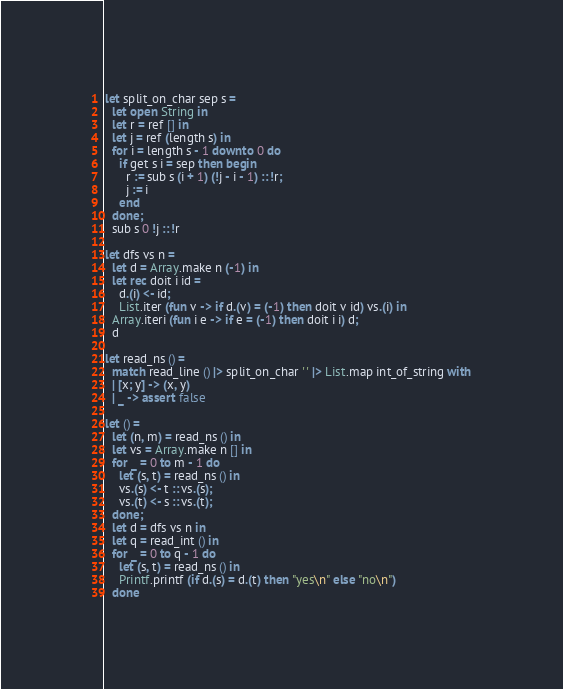<code> <loc_0><loc_0><loc_500><loc_500><_OCaml_>let split_on_char sep s =
  let open String in
  let r = ref [] in
  let j = ref (length s) in
  for i = length s - 1 downto 0 do
    if get s i = sep then begin
      r := sub s (i + 1) (!j - i - 1) :: !r;
      j := i
    end
  done;
  sub s 0 !j :: !r

let dfs vs n =
  let d = Array.make n (-1) in
  let rec doit i id =
    d.(i) <- id;
    List.iter (fun v -> if d.(v) = (-1) then doit v id) vs.(i) in
  Array.iteri (fun i e -> if e = (-1) then doit i i) d;
  d

let read_ns () =
  match read_line () |> split_on_char ' ' |> List.map int_of_string with
  | [x; y] -> (x, y)
  | _ -> assert false

let () =
  let (n, m) = read_ns () in
  let vs = Array.make n [] in
  for _ = 0 to m - 1 do
    let (s, t) = read_ns () in
    vs.(s) <- t :: vs.(s);
    vs.(t) <- s :: vs.(t);
  done;
  let d = dfs vs n in
  let q = read_int () in
  for _ = 0 to q - 1 do
    let (s, t) = read_ns () in
    Printf.printf (if d.(s) = d.(t) then "yes\n" else "no\n")
  done</code> 